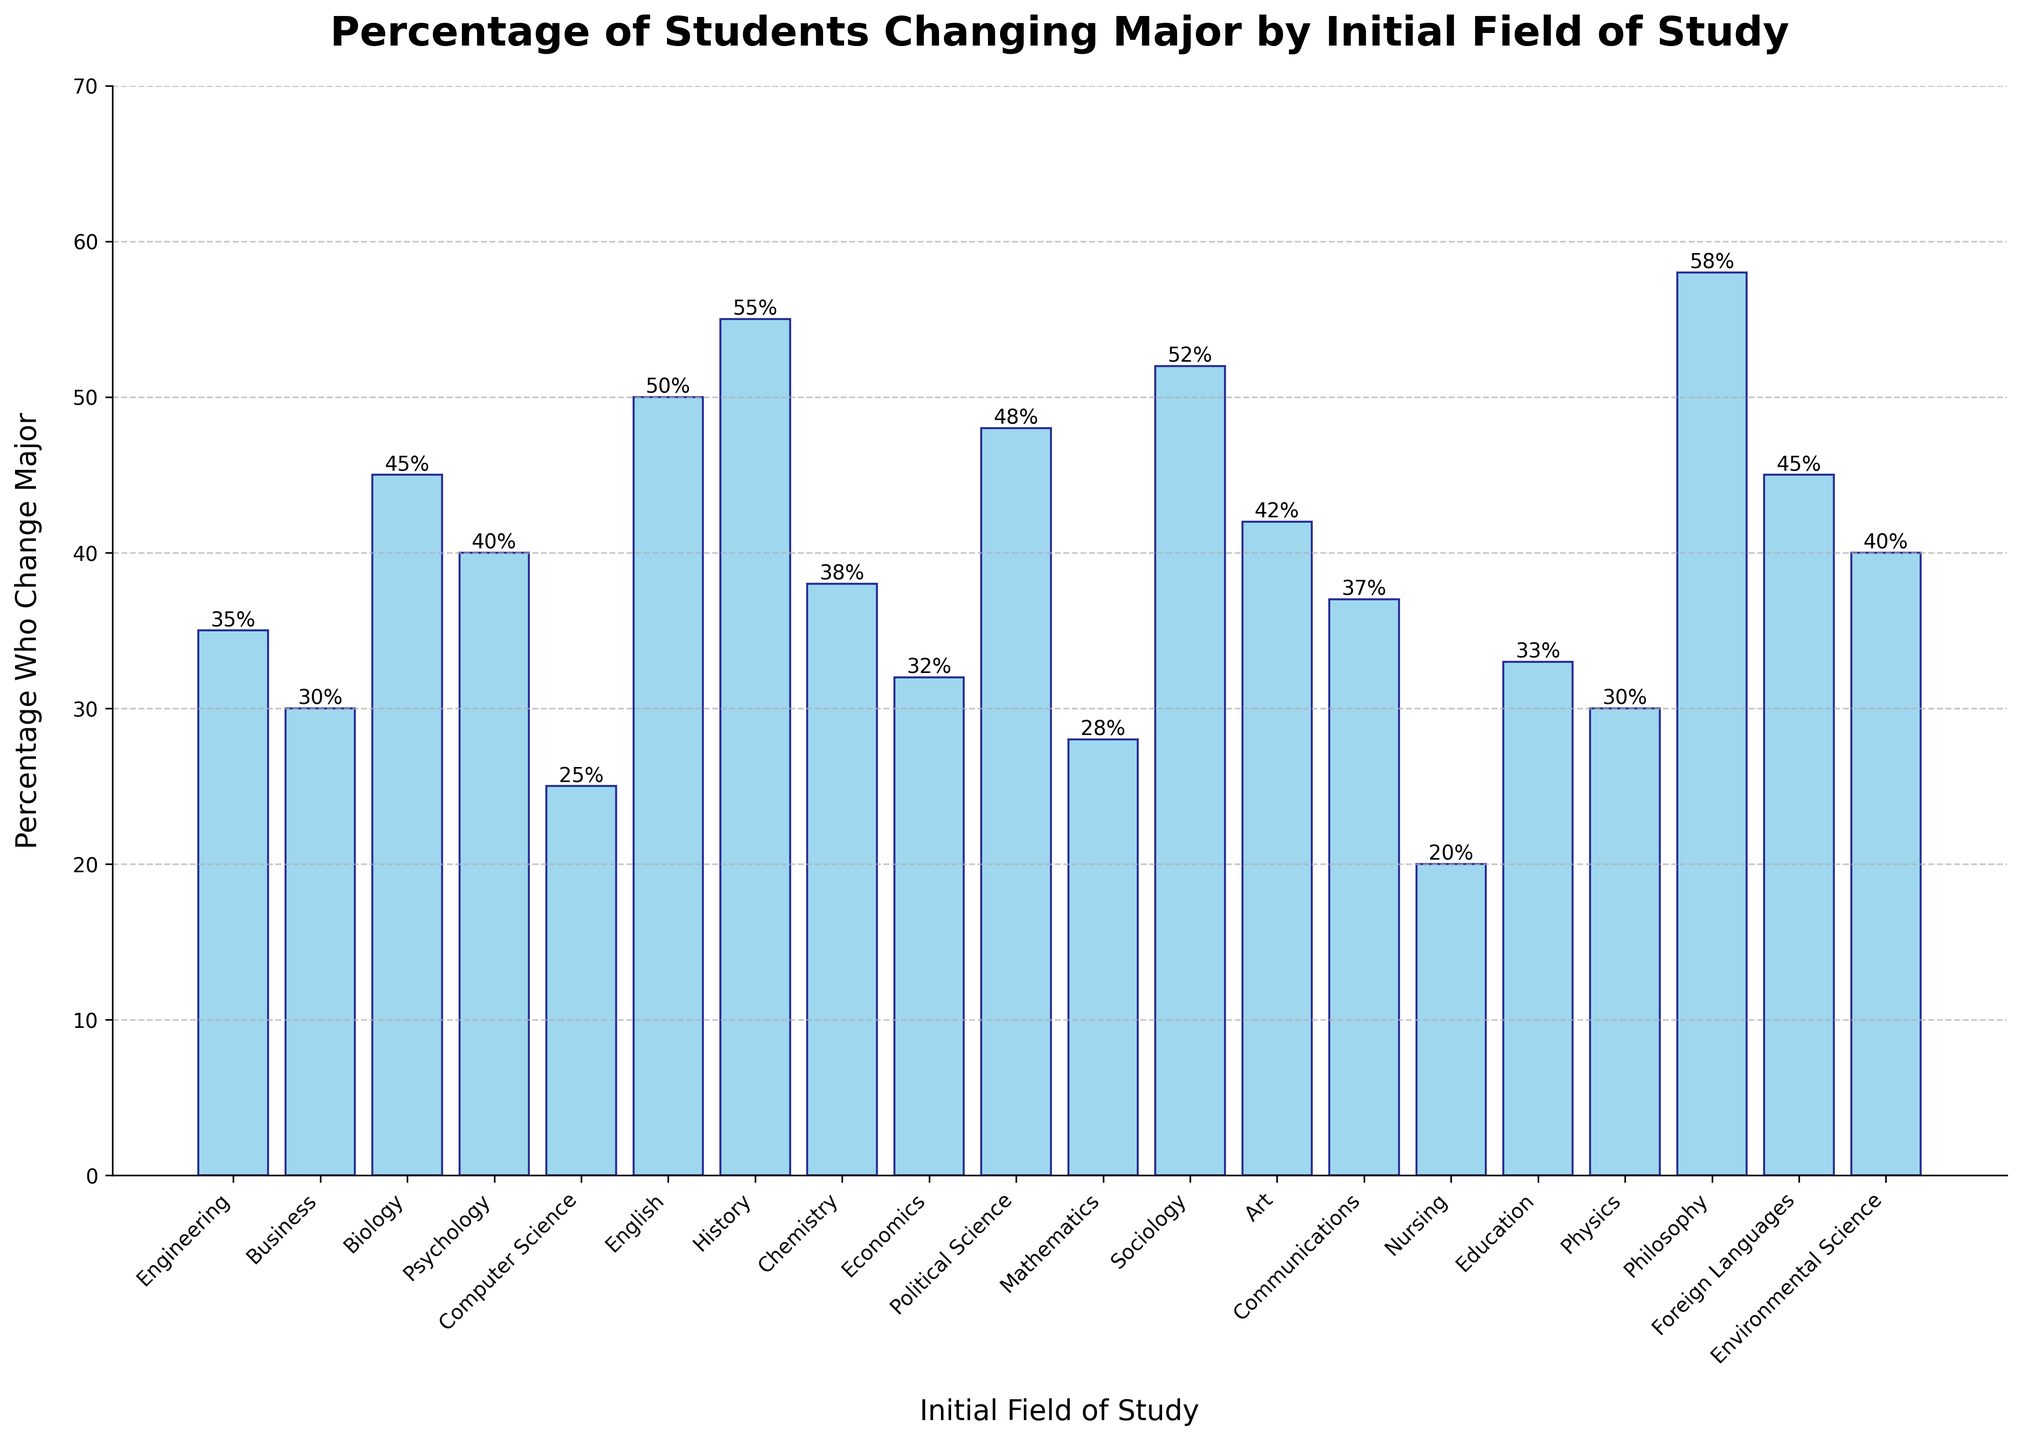Which field of study has the highest percentage of students changing their major? Based on the bar heights in the figure, Philosophy has the highest percentage at 58%.
Answer: Philosophy Which field of study has the second lowest percentage of students changing their major? After first identifying Nursing with the lowest percentage at 20%, Computer Science is next with 25%.
Answer: Computer Science What is the total percentage of students who change their major for Engineering, Business, and Biology combined? Adding the percentages for Engineering (35%), Business (30%), and Biology (45%) gives: 35 + 30 + 45 = 110%.
Answer: 110% Which initial field of study has a higher percentage of students changing their major: Sociology or Political Science? Comparing the bar heights, Sociology is 52% and Political Science is 48%.
Answer: Sociology How many fields of study have a change rate percentage of 40% or more? Count the bars with height 40% or more: Biology, Psychology, English, History, Sociology, Art, Political Science, Philosophy, Foreign Languages, Environmental Science; this totals 10 fields.
Answer: 10 Between Nursing and Education, which field has a higher percentage of students changing their major? Comparing the heights, Nursing is 20% and Education is 33%.
Answer: Education Is the percentage of students changing their major in Chemistry closer to the lowest or highest percentage? The lowest is Nursing at 20%, and the highest is Philosophy at 58%; Chemistry is at 38%, which is closer to the lowest (20%).
Answer: Closest to lowest Calculate the average percentage of students changing their major across all fields of study presented in the figure. Sum the percentages (35 + 30 + 45 + 40 + 25 + 50 + 55 + 38 + 32 + 48 + 28 + 52 + 42 + 37 + 20 + 33 + 30 + 58 + 45 + 40 = 783) and divide by 20 fields: 783/20 = 39.15%.
Answer: 39.15% Which initial field of study has a higher percentage of students changing their major: Mathematics or Chemistry? Comparing the heights, Mathematics is 28% and Chemistry is 38%.
Answer: Chemistry 